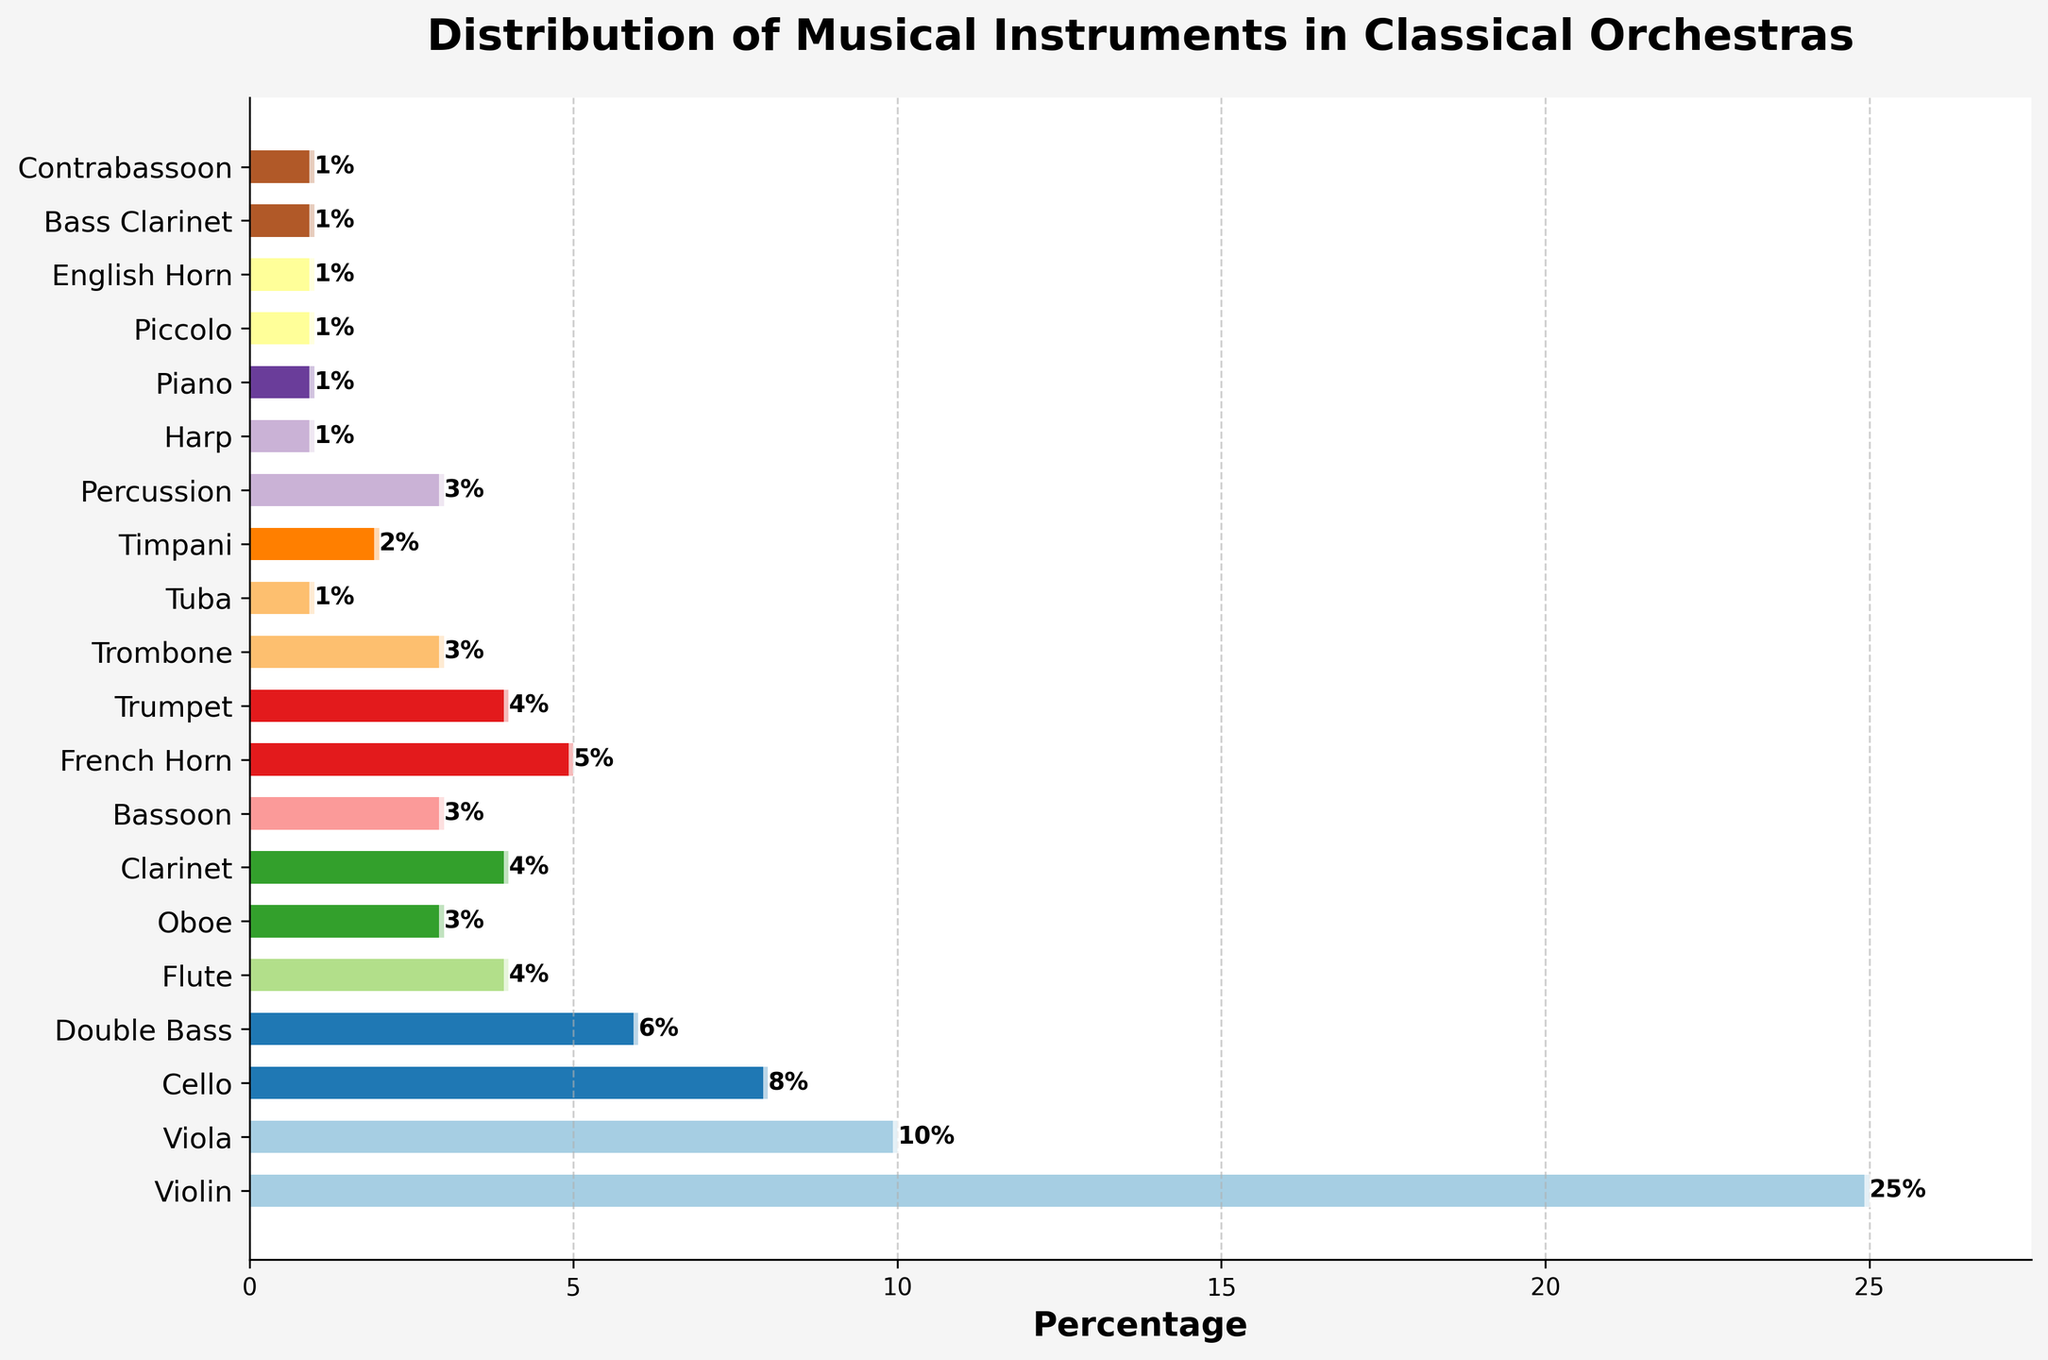what percentage of instruments are played by strings (Violin, Viola, Cello, Double Bass)? Adding the percentages of Violin (25%), Viola (10%), Cello (8%), and Double Bass (6%) gives 25 + 10 + 8 + 6 = 49%.
Answer: 49% which instrument has the lowest percentage and what is that percentage? The bar corresponding to Tuba, Harp, Piano, Piccolo, English Horn, Bass Clarinet, and Contrabassoon have the smallest height, each having a value of 1%.
Answer: Tuba, Harp, Piano, Piccolo, English Horn, Bass Clarinet, Contrabassoon, 1% how does the percentage of Violin players compare to the percentage of Flute players? The bar corresponding to Violin is 25%, and the bar corresponding to Flute is 4%. Comparing 25% with 4%, 25% is greater.
Answer: Violin has a higher percentage at 25% compared to Flute at 4% what is the combined percentage of wind instruments (Flute, Oboe, Clarinet, Bassoon)? Adding the percentages of Flute (4%), Oboe (3%), Clarinet (4%), and Bassoon (3%) gives 4 + 3 + 4 + 3 = 14%.
Answer: 14% how many instruments have a percentage greater than 5%? The bars represented by Violin (25%), Viola (10%), and Cello (8%) have percentages greater than 5%. That's three instruments.
Answer: 3 what is the percentage difference between Violin and Viola? Subtracting the percentage of Viola (10%) from that of Violin (25%) gives 25 - 10 = 15%.
Answer: 15% which instrument category constitutes exactly 3% each? The bars at 3% are for Oboe, Bassoon, Trombone, and Percussion.
Answer: Oboe, Bassoon, Trombone, Percussion what is the average percentage of Brass instruments (French Horn, Trumpet, Trombone, Tuba)? Adding the percentages of French Horn (5%), Trumpet (4%), Trombone (3%), and Tuba (1%) gives 5 + 4 + 3 + 1 = 13%. Dividing by 4 gives 13 / 4 = 3.25%.
Answer: 3.25% which instrument bar is the longest and what is its percentage? The Violin bar is the longest in height and has a percentage of 25%.
Answer: Violin, 25% if you add up the percentages of Woodwind instruments (Flute, Oboe, Clarinet, Bassoon, Piccolo, English Horn, Bass Clarinet, Contrabassoon), what is the total? Adding percentages of Flute (4%), Oboe (3%), Clarinet (4%), Bassoon (3%), Piccolo (1%), English Horn (1%), Bass Clarinet (1%), and Contrabassoon (1%) gives 4 + 3 + 4 + 3 + 1 + 1 + 1 + 1 = 18%.
Answer: 18% 